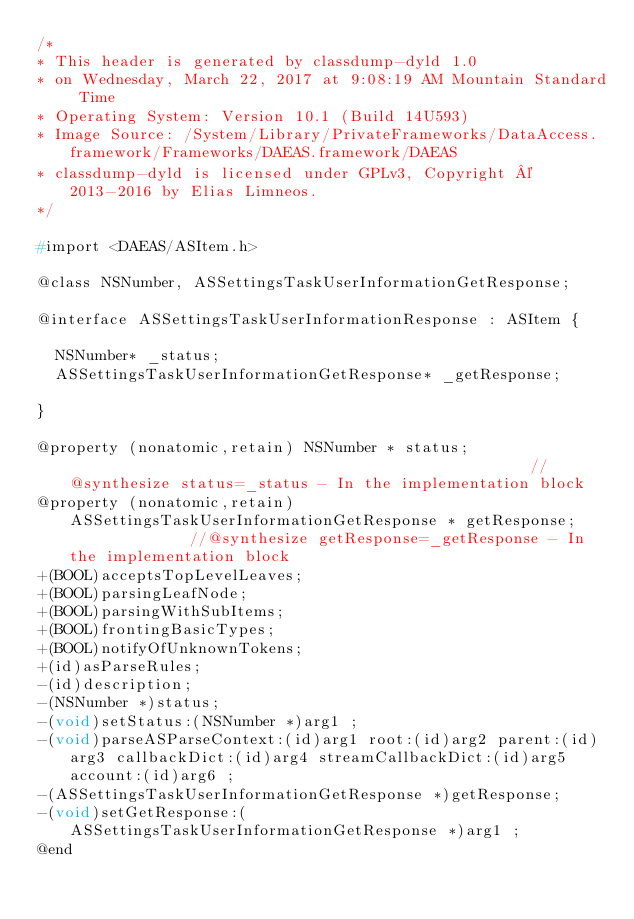Convert code to text. <code><loc_0><loc_0><loc_500><loc_500><_C_>/*
* This header is generated by classdump-dyld 1.0
* on Wednesday, March 22, 2017 at 9:08:19 AM Mountain Standard Time
* Operating System: Version 10.1 (Build 14U593)
* Image Source: /System/Library/PrivateFrameworks/DataAccess.framework/Frameworks/DAEAS.framework/DAEAS
* classdump-dyld is licensed under GPLv3, Copyright © 2013-2016 by Elias Limneos.
*/

#import <DAEAS/ASItem.h>

@class NSNumber, ASSettingsTaskUserInformationGetResponse;

@interface ASSettingsTaskUserInformationResponse : ASItem {

	NSNumber* _status;
	ASSettingsTaskUserInformationGetResponse* _getResponse;

}

@property (nonatomic,retain) NSNumber * status;                                                   //@synthesize status=_status - In the implementation block
@property (nonatomic,retain) ASSettingsTaskUserInformationGetResponse * getResponse;              //@synthesize getResponse=_getResponse - In the implementation block
+(BOOL)acceptsTopLevelLeaves;
+(BOOL)parsingLeafNode;
+(BOOL)parsingWithSubItems;
+(BOOL)frontingBasicTypes;
+(BOOL)notifyOfUnknownTokens;
+(id)asParseRules;
-(id)description;
-(NSNumber *)status;
-(void)setStatus:(NSNumber *)arg1 ;
-(void)parseASParseContext:(id)arg1 root:(id)arg2 parent:(id)arg3 callbackDict:(id)arg4 streamCallbackDict:(id)arg5 account:(id)arg6 ;
-(ASSettingsTaskUserInformationGetResponse *)getResponse;
-(void)setGetResponse:(ASSettingsTaskUserInformationGetResponse *)arg1 ;
@end

</code> 